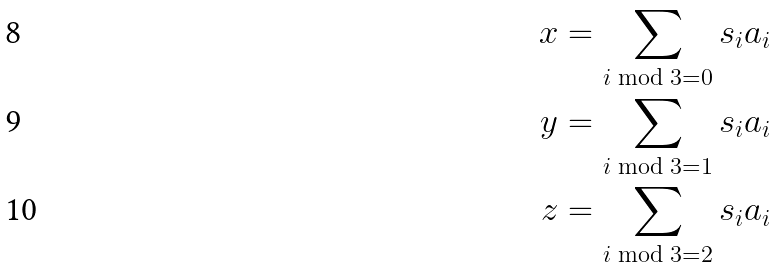<formula> <loc_0><loc_0><loc_500><loc_500>x & = \sum _ { i \bmod 3 = 0 } s _ { i } a _ { i } \\ y & = \sum _ { i \bmod 3 = 1 } s _ { i } a _ { i } \\ z & = \sum _ { i \bmod 3 = 2 } s _ { i } a _ { i }</formula> 